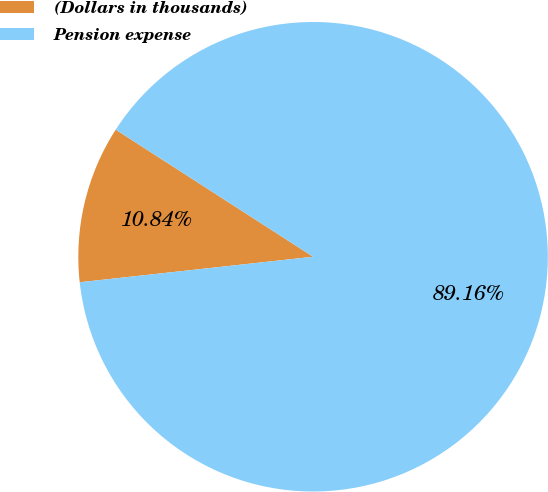<chart> <loc_0><loc_0><loc_500><loc_500><pie_chart><fcel>(Dollars in thousands)<fcel>Pension expense<nl><fcel>10.84%<fcel>89.16%<nl></chart> 